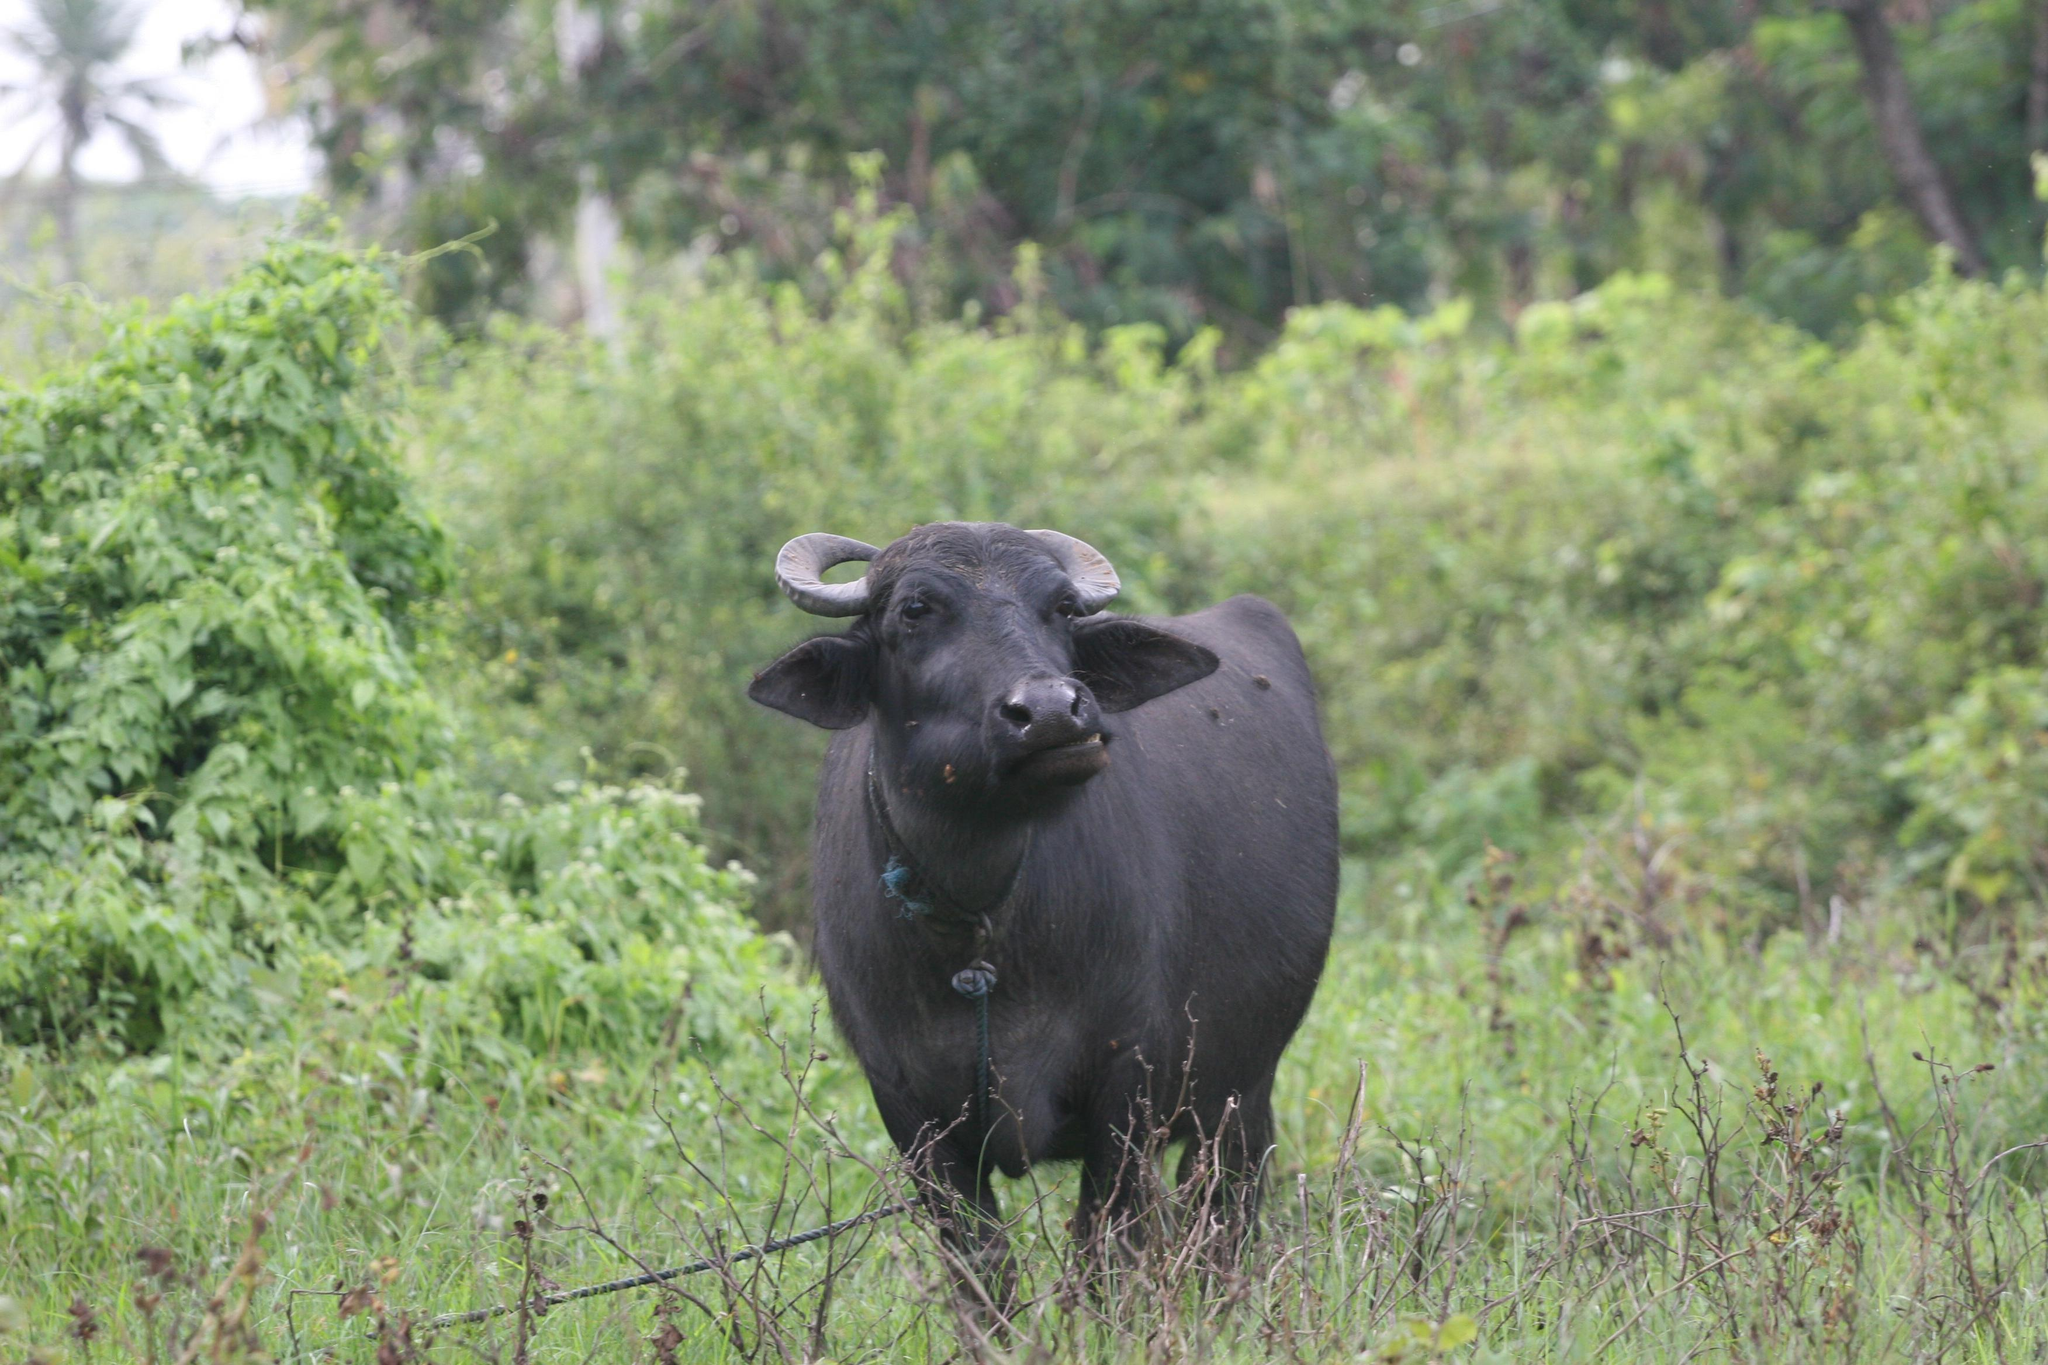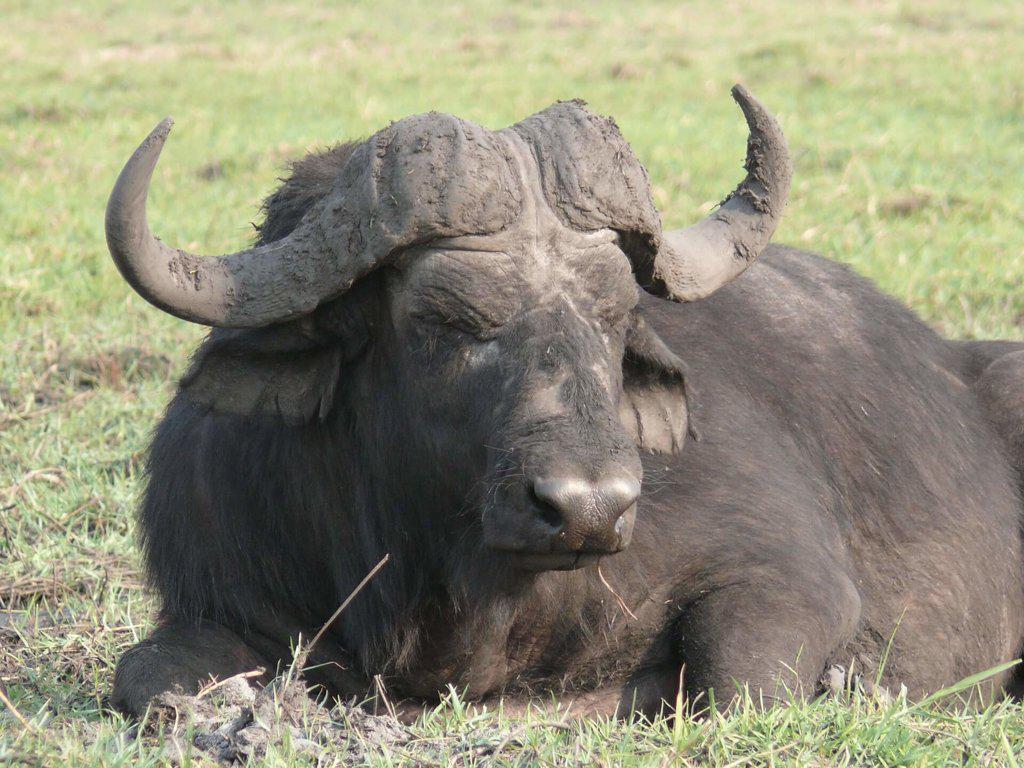The first image is the image on the left, the second image is the image on the right. Evaluate the accuracy of this statement regarding the images: "There are two buffalo.". Is it true? Answer yes or no. Yes. 